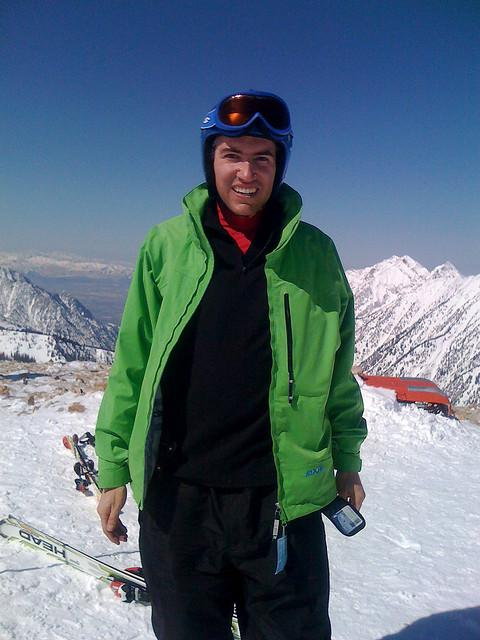What type of telephone is he using? Please explain your reasoning. cellular. Because he's outdoors and not near a power source. 